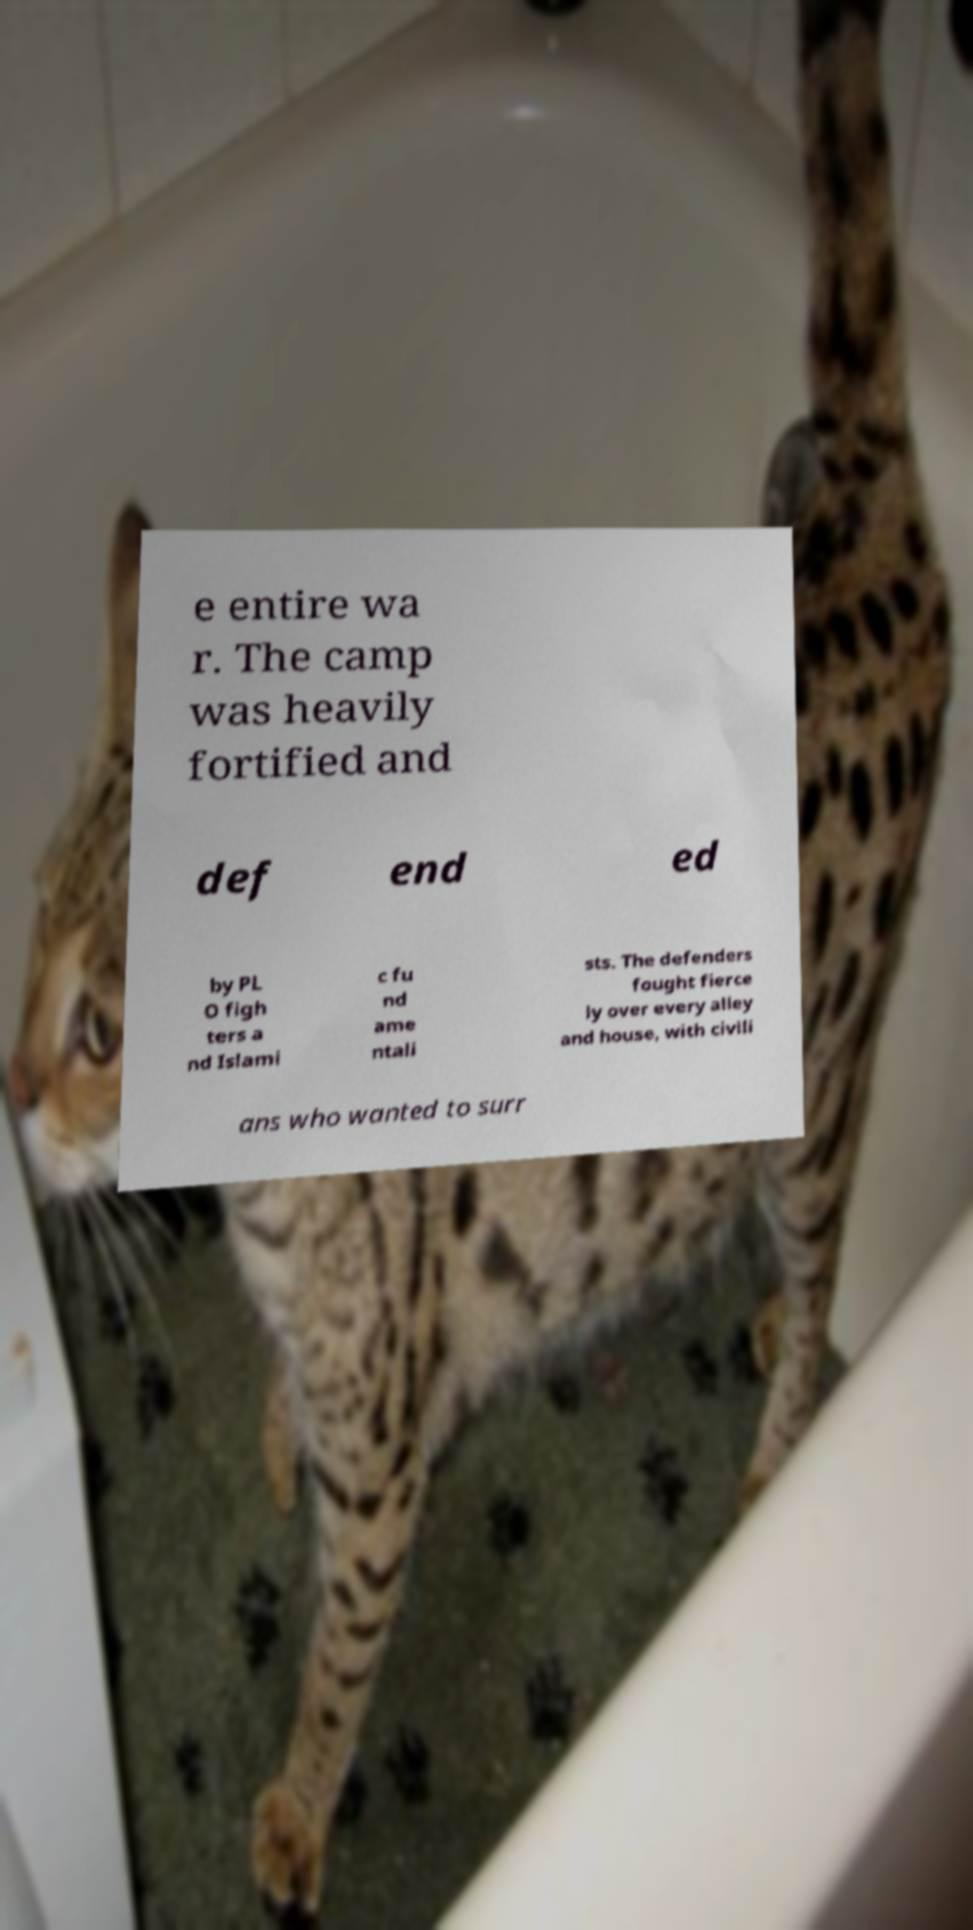What messages or text are displayed in this image? I need them in a readable, typed format. e entire wa r. The camp was heavily fortified and def end ed by PL O figh ters a nd Islami c fu nd ame ntali sts. The defenders fought fierce ly over every alley and house, with civili ans who wanted to surr 